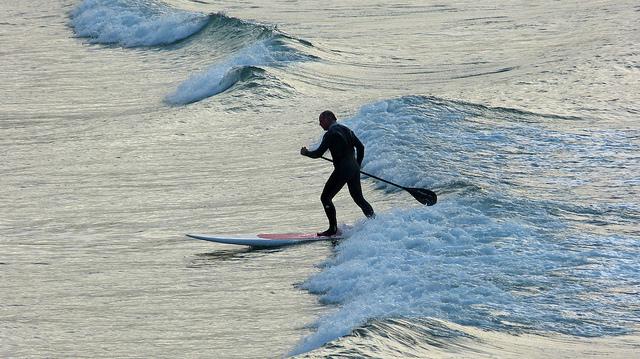Does the person have a paddle?
Be succinct. Yes. Who took the photograph?
Concise answer only. Photographer. Is this person wearing a swimsuit?
Keep it brief. Yes. Where is the person?
Write a very short answer. Water. 